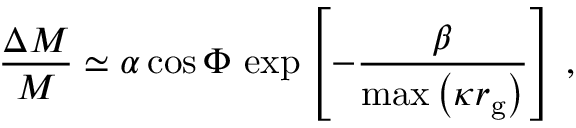Convert formula to latex. <formula><loc_0><loc_0><loc_500><loc_500>\frac { \Delta M } { M } \simeq \alpha \cos \Phi \, \exp \left [ - \frac { \beta } { \max \left ( \kappa r _ { g } \right ) } \right ] \, ,</formula> 